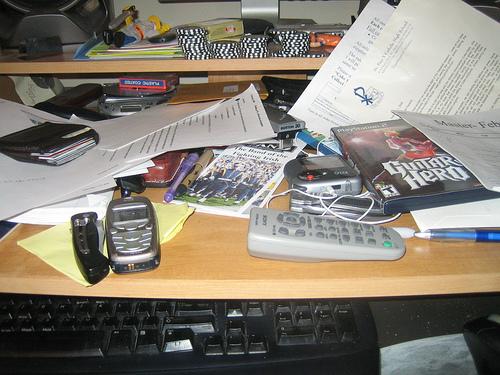How many remotes do you see?
Be succinct. 1. What video game is sitting on the desk?
Be succinct. Guitar hero. What objects are black and white striped in the background?
Write a very short answer. Chips. 